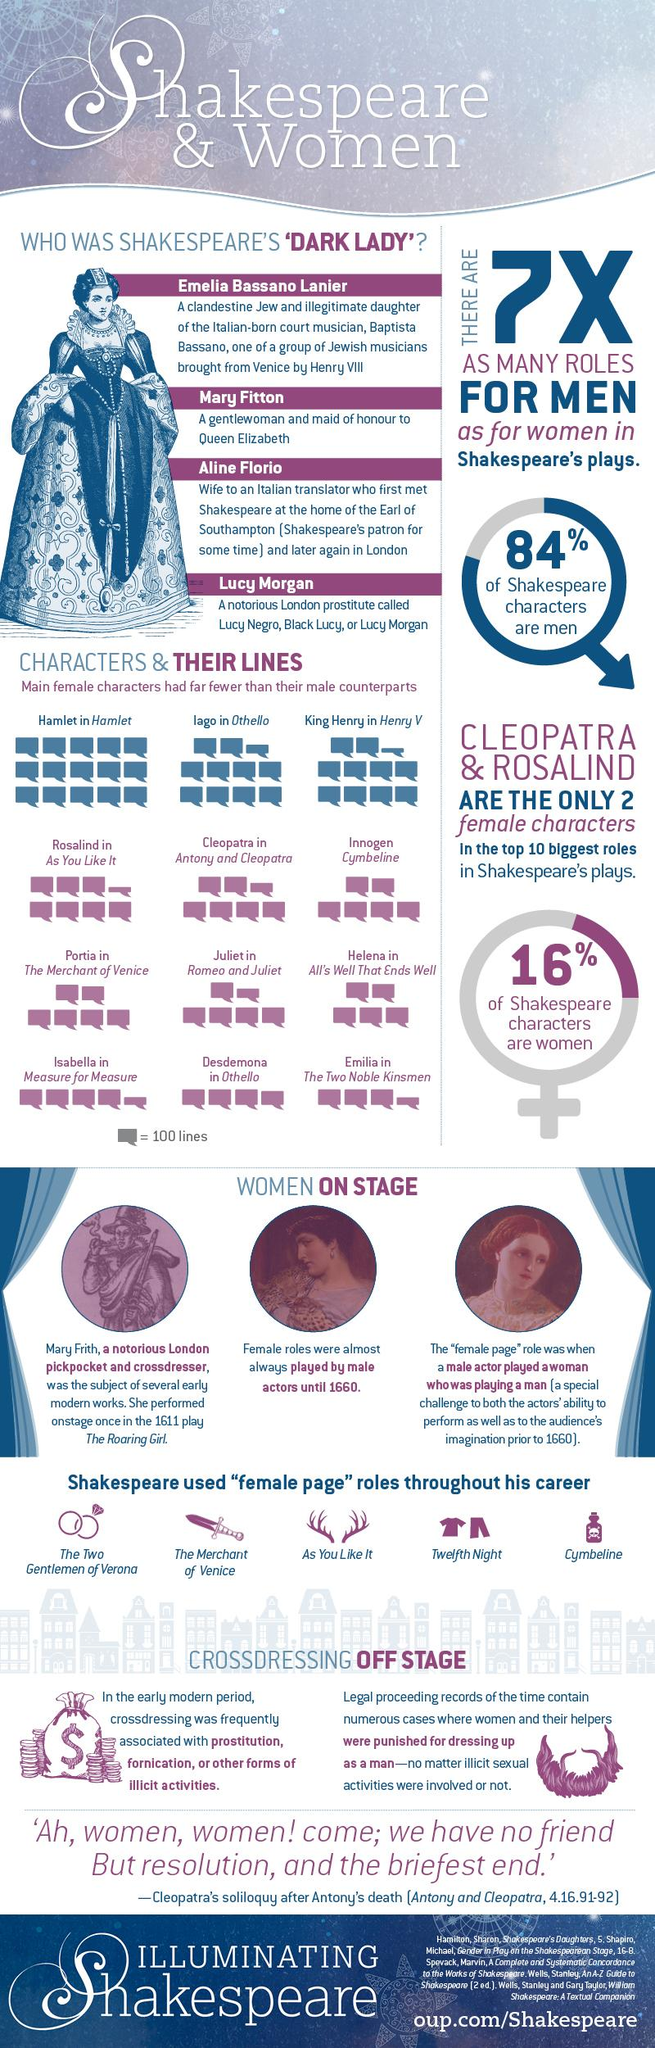Specify some key components in this picture. Rosalind had 725 lines in "As You Like It. Cleopatra had approximately 650 lines in "Antony and Cleopatra. The Shakespearean novel featuring a female character who says approximately 400 lines is 'Othello.' Emilia, a woman character in Shakespeare's play, had the least number of lines in the entire play. 